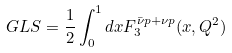Convert formula to latex. <formula><loc_0><loc_0><loc_500><loc_500>G L S = \frac { 1 } { 2 } \int _ { 0 } ^ { 1 } d x F ^ { \bar { \nu } p + \nu p } _ { 3 } ( x , Q ^ { 2 } )</formula> 